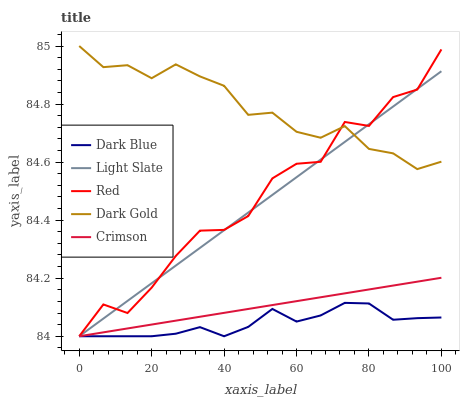Does Crimson have the minimum area under the curve?
Answer yes or no. No. Does Crimson have the maximum area under the curve?
Answer yes or no. No. Is Dark Blue the smoothest?
Answer yes or no. No. Is Dark Blue the roughest?
Answer yes or no. No. Does Dark Gold have the lowest value?
Answer yes or no. No. Does Crimson have the highest value?
Answer yes or no. No. Is Dark Blue less than Dark Gold?
Answer yes or no. Yes. Is Dark Gold greater than Dark Blue?
Answer yes or no. Yes. Does Dark Blue intersect Dark Gold?
Answer yes or no. No. 